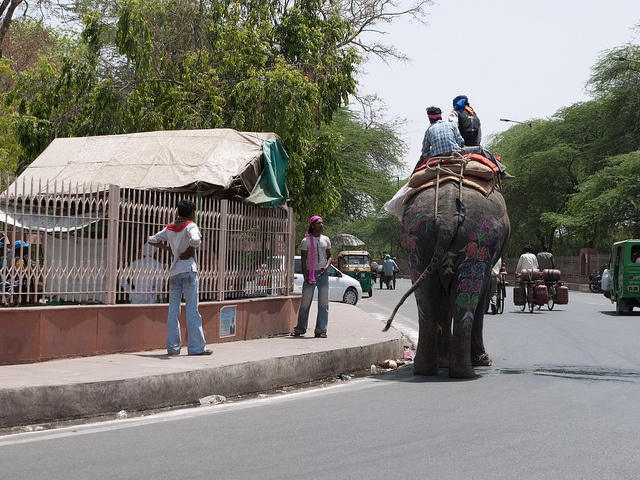Describe the objects in this image and their specific colors. I can see elephant in lavender, black, gray, and darkgray tones, people in lavender, gray, and black tones, people in lavender, black, gray, and purple tones, truck in lavender, black, darkgreen, gray, and teal tones, and people in lavender, gray, and darkgray tones in this image. 